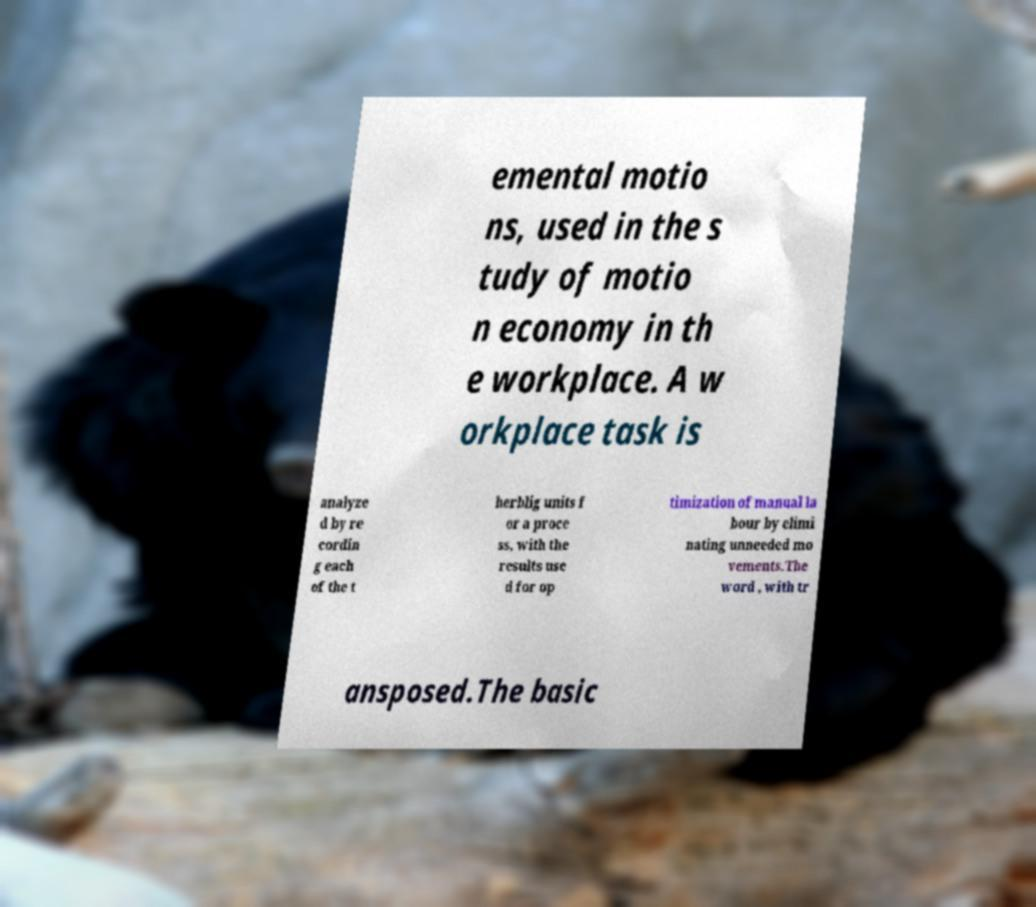Can you read and provide the text displayed in the image?This photo seems to have some interesting text. Can you extract and type it out for me? emental motio ns, used in the s tudy of motio n economy in th e workplace. A w orkplace task is analyze d by re cordin g each of the t herblig units f or a proce ss, with the results use d for op timization of manual la bour by elimi nating unneeded mo vements.The word , with tr ansposed.The basic 